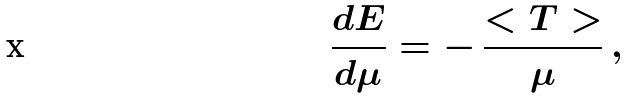<formula> <loc_0><loc_0><loc_500><loc_500>\frac { d E } { d \mu } = - \, \frac { < T > } { \mu } \, ,</formula> 